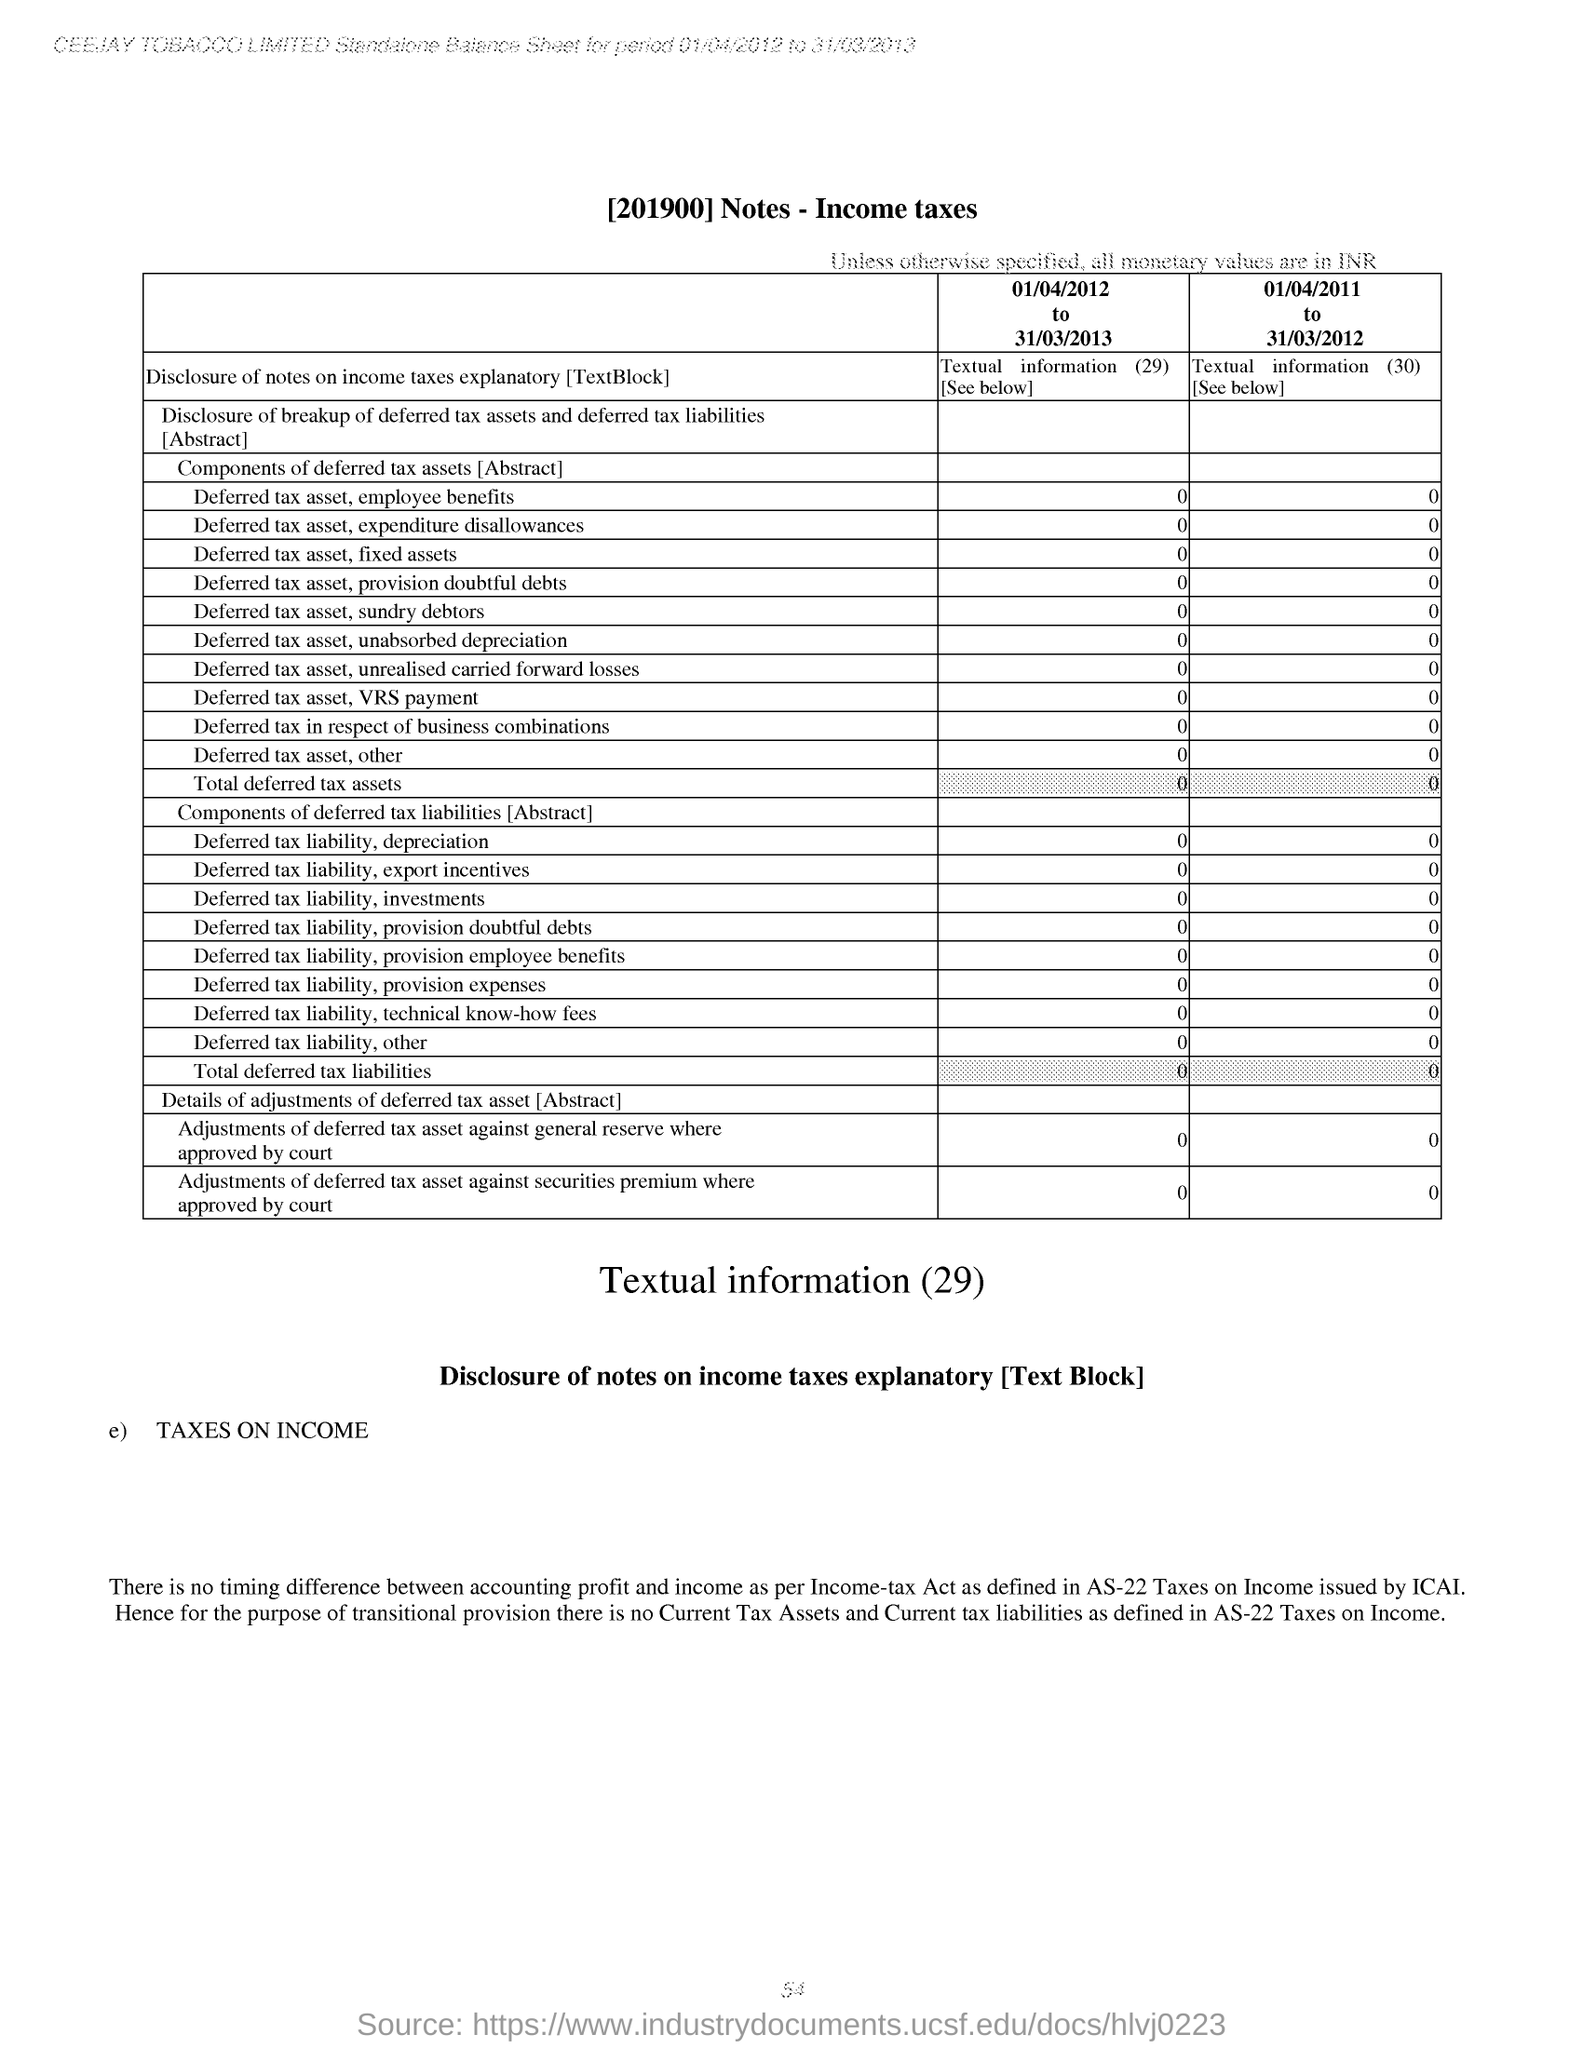What is the Deferred tax asset,fixed assets for 01/04/2012 to 31/03/2013?
Ensure brevity in your answer.  0. What is the Deferred tax asset,sundry debtors for 01/04/2012 to 31/03/2013?
Offer a very short reply. 0. What is the Deferred tax asset,other for 01/04/2012 to 31/03/2013?
Your answer should be very brief. 0. What is the Deferred tax asset,employee benefits for 01/04/2012 to 31/03/2013?
Offer a very short reply. 0. What is the Deferred tax asset,VRS Payment for 01/04/2012 to 31/03/2013?
Your answer should be very brief. 0. What is the Total Deferred tax assets for 01/04/2012 to 31/03/2013?
Your response must be concise. 0. What is the Deferred tax asset,expenditure disallowances for 01/04/2012 to 31/03/2013?
Give a very brief answer. 0. What is the Deferred tax asset,Provision doubtful debts for 01/04/2012 to 31/03/2013?
Ensure brevity in your answer.  0. 